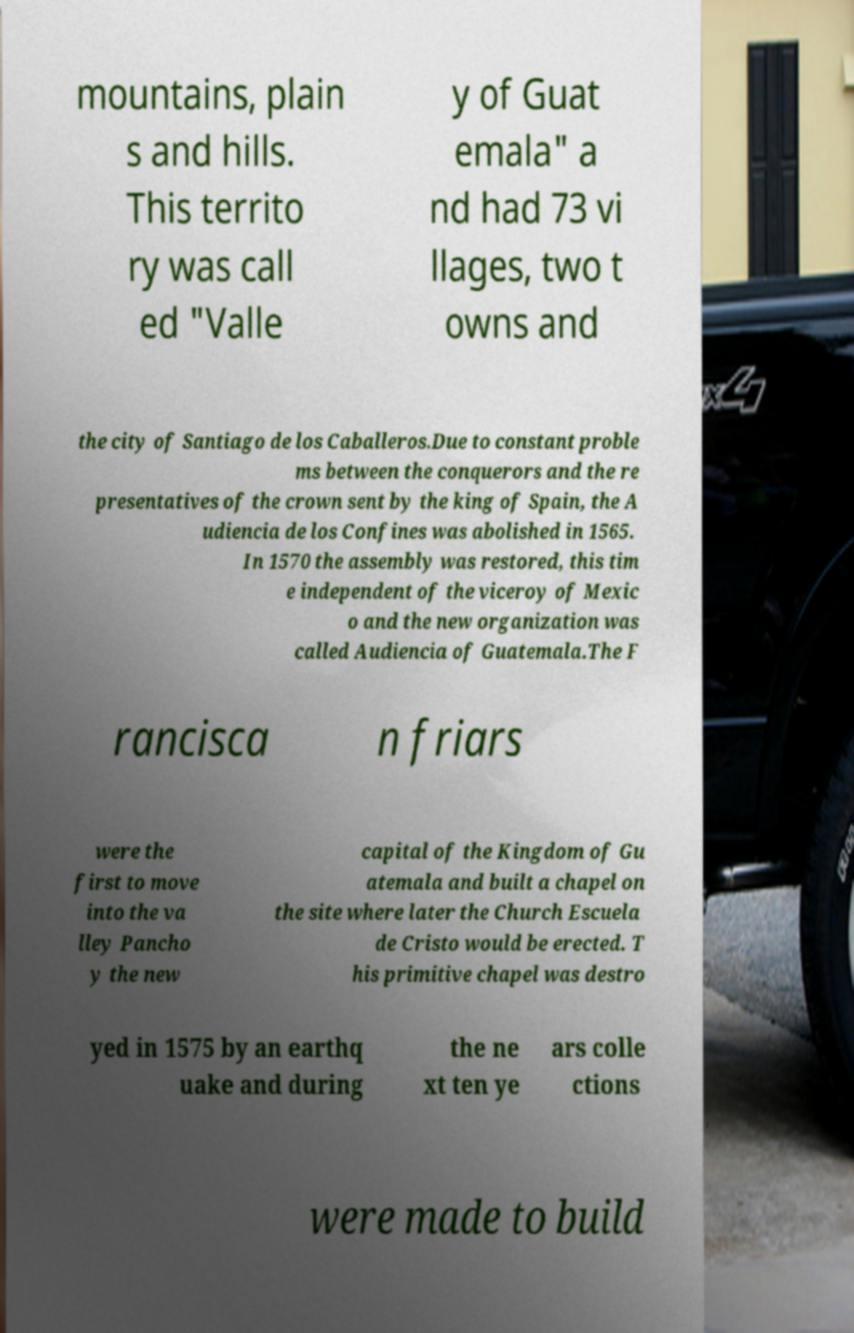Could you extract and type out the text from this image? mountains, plain s and hills. This territo ry was call ed "Valle y of Guat emala" a nd had 73 vi llages, two t owns and the city of Santiago de los Caballeros.Due to constant proble ms between the conquerors and the re presentatives of the crown sent by the king of Spain, the A udiencia de los Confines was abolished in 1565. In 1570 the assembly was restored, this tim e independent of the viceroy of Mexic o and the new organization was called Audiencia of Guatemala.The F rancisca n friars were the first to move into the va lley Pancho y the new capital of the Kingdom of Gu atemala and built a chapel on the site where later the Church Escuela de Cristo would be erected. T his primitive chapel was destro yed in 1575 by an earthq uake and during the ne xt ten ye ars colle ctions were made to build 